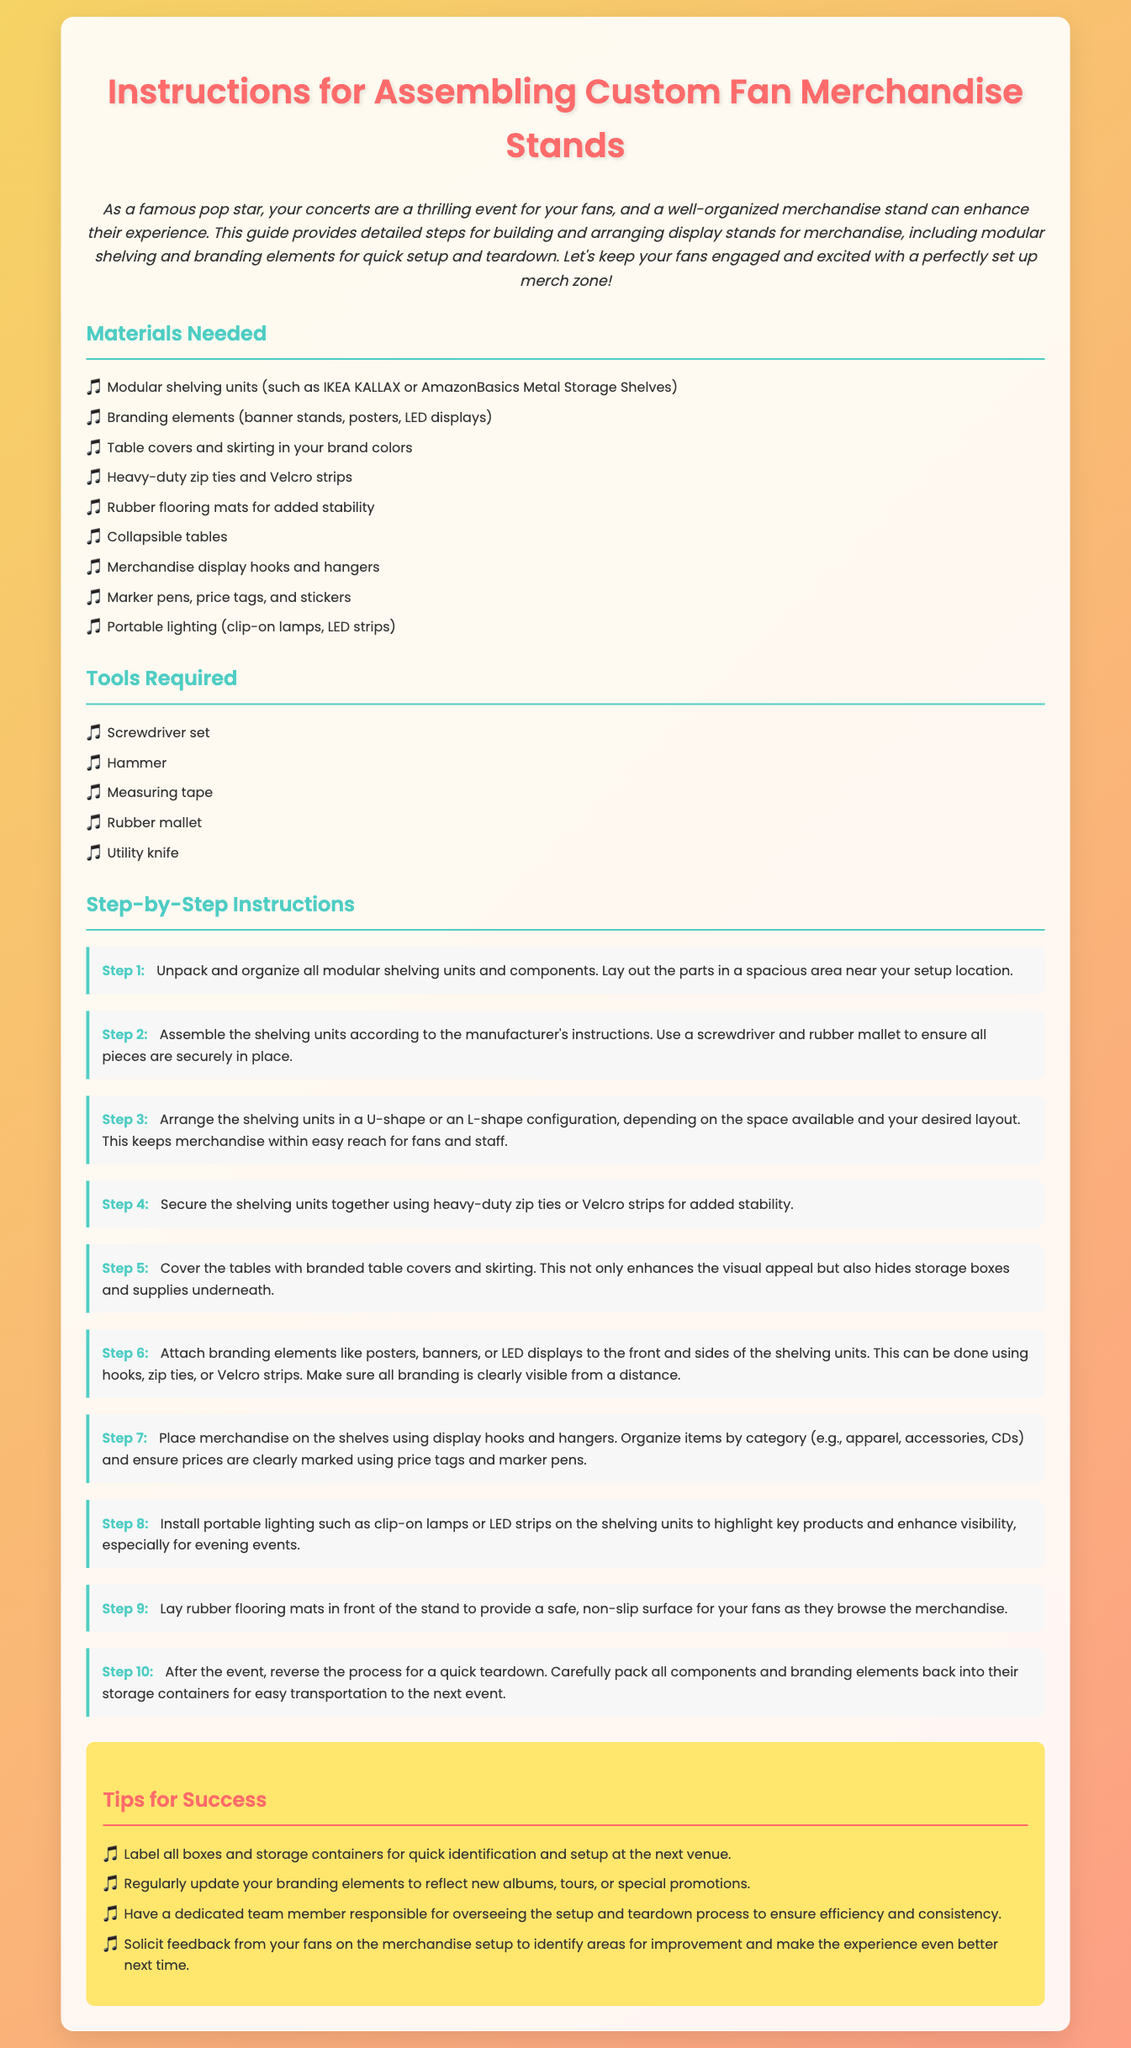What is the main purpose of this document? The document serves as a guide for assembling and organizing display stands for merchandise at concerts, enhancing fan experience.
Answer: Guide for assembling merchandise stands How many steps are there in the assembly instructions? The document lists a total of ten steps for assembling the merchandise stands.
Answer: Ten What type of shelving units are mentioned? The document specifically mentions modular shelving units like IKEA KALLAX and AmazonBasics Metal Storage Shelves.
Answer: IKEA KALLAX or AmazonBasics Metal Storage Shelves What tool is needed to secure the shelving units together? The document indicates that heavy-duty zip ties or Velcro strips are used for securing shelving units together.
Answer: Zip ties or Velcro strips In which shape should the shelving units be arranged? The document suggests arranging the shelving units in a U-shape or an L-shape configuration.
Answer: U-shape or L-shape What is one tip provided for successful merchandise setup? One of the tips mentions regularly updating branding elements to reflect new albums, tours, or special promotions.
Answer: Update branding elements What flooring is recommended for the merchandise stand? The document recommends using rubber flooring mats for added stability and safety.
Answer: Rubber flooring mats What should be laid out before start assembling? The document advises unpacking and organizing all modular shelving units and components in a spacious area.
Answer: Modular shelving units and components What is the last step in the teardown process? The document concludes with carefully packing all components and branding elements back into their storage containers.
Answer: Packing all components How should merchandise be organized on shelves? The document states that items should be organized by category, such as apparel, accessories, and CDs.
Answer: By category 